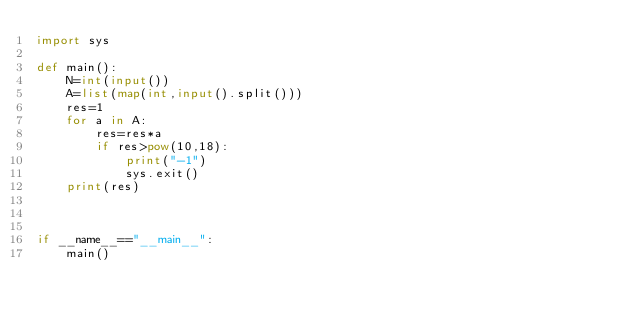<code> <loc_0><loc_0><loc_500><loc_500><_Python_>import sys

def main():
    N=int(input())
    A=list(map(int,input().split()))
    res=1
    for a in A:
        res=res*a
        if res>pow(10,18):
            print("-1")
            sys.exit()
    print(res)
        
    
    
if __name__=="__main__":
    main()
    </code> 